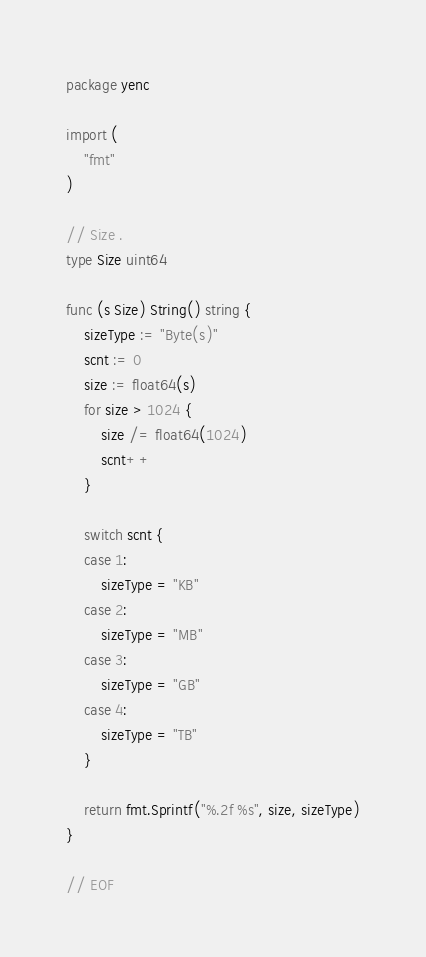Convert code to text. <code><loc_0><loc_0><loc_500><loc_500><_Go_>package yenc

import (
    "fmt"
)

// Size .
type Size uint64

func (s Size) String() string {
    sizeType := "Byte(s)"
    scnt := 0
    size := float64(s)
    for size > 1024 {
        size /= float64(1024)
        scnt++
    }

    switch scnt {
    case 1:
        sizeType = "KB"
    case 2:
        sizeType = "MB"
    case 3:
        sizeType = "GB"
    case 4:
        sizeType = "TB"
    }

    return fmt.Sprintf("%.2f %s", size, sizeType)
}

// EOF
</code> 